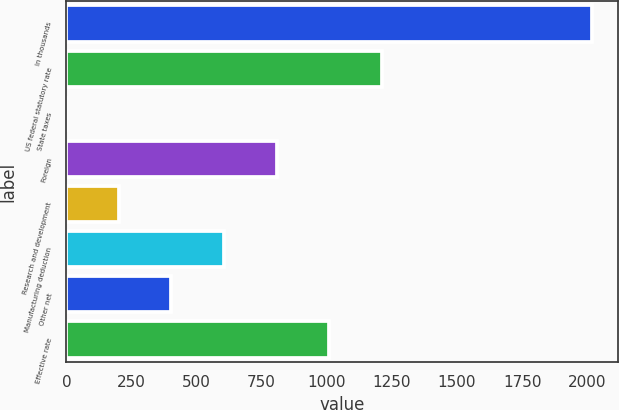Convert chart to OTSL. <chart><loc_0><loc_0><loc_500><loc_500><bar_chart><fcel>In thousands<fcel>US federal statutory rate<fcel>State taxes<fcel>Foreign<fcel>Research and development<fcel>Manufacturing deduction<fcel>Other net<fcel>Effective rate<nl><fcel>2017<fcel>1210.36<fcel>0.4<fcel>807.04<fcel>202.06<fcel>605.38<fcel>403.72<fcel>1008.7<nl></chart> 